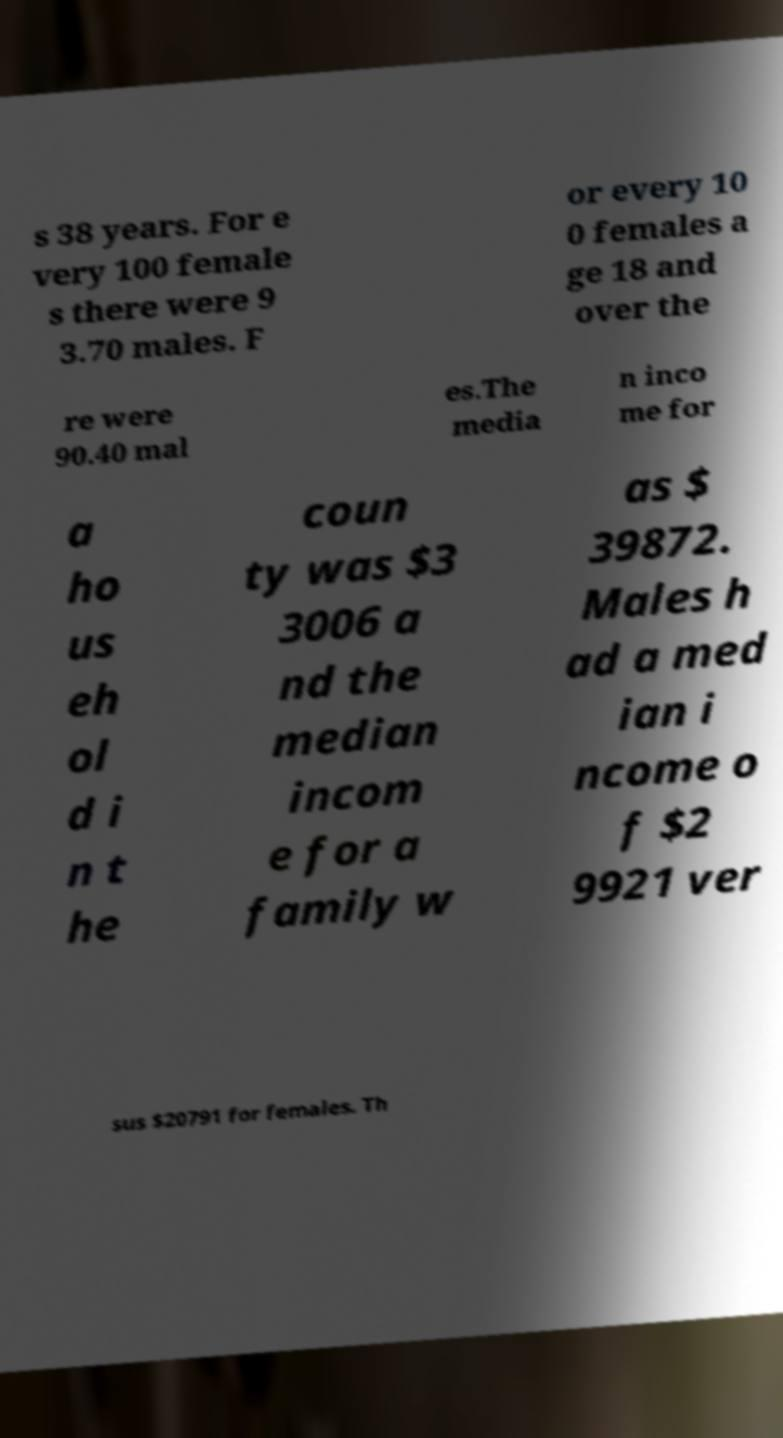I need the written content from this picture converted into text. Can you do that? s 38 years. For e very 100 female s there were 9 3.70 males. F or every 10 0 females a ge 18 and over the re were 90.40 mal es.The media n inco me for a ho us eh ol d i n t he coun ty was $3 3006 a nd the median incom e for a family w as $ 39872. Males h ad a med ian i ncome o f $2 9921 ver sus $20791 for females. Th 